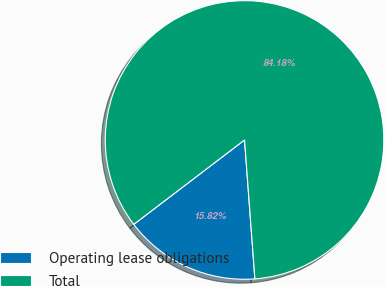Convert chart to OTSL. <chart><loc_0><loc_0><loc_500><loc_500><pie_chart><fcel>Operating lease obligations<fcel>Total<nl><fcel>15.82%<fcel>84.18%<nl></chart> 